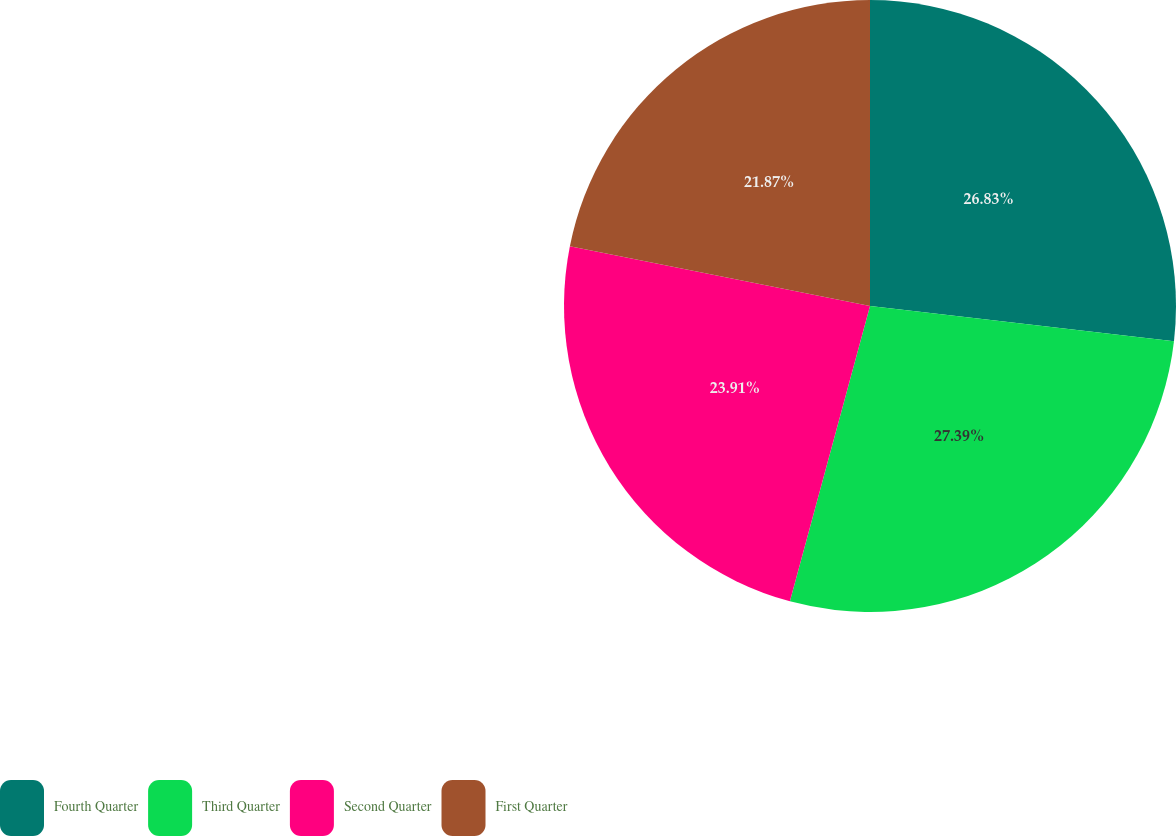<chart> <loc_0><loc_0><loc_500><loc_500><pie_chart><fcel>Fourth Quarter<fcel>Third Quarter<fcel>Second Quarter<fcel>First Quarter<nl><fcel>26.83%<fcel>27.38%<fcel>23.91%<fcel>21.87%<nl></chart> 